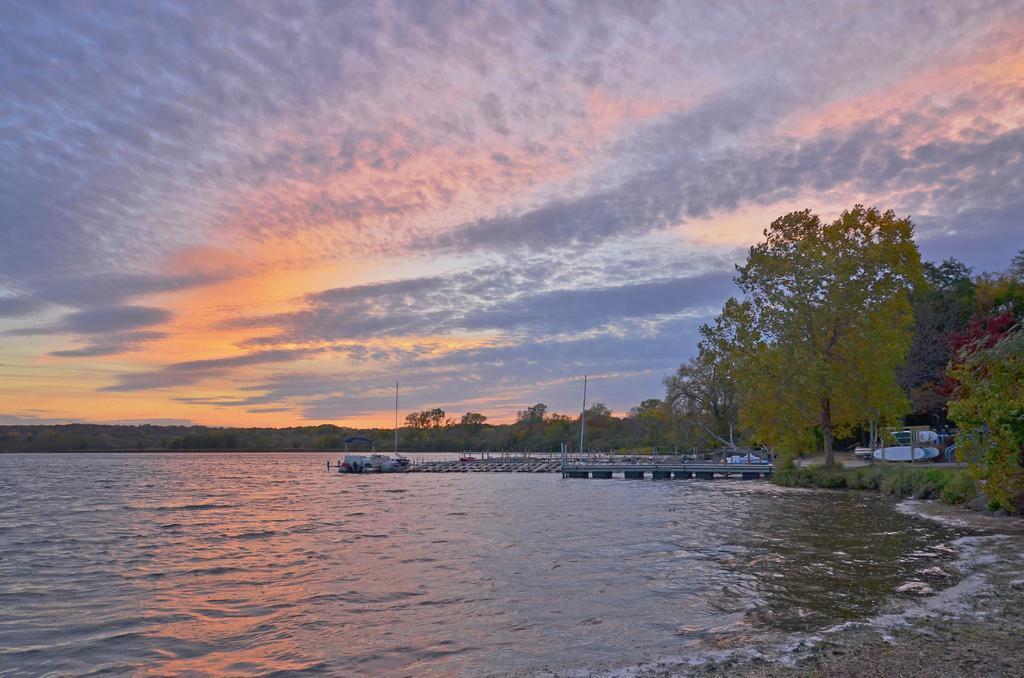Can you describe this image briefly? In this picture we can see water, trees, poles, sky and other things. 